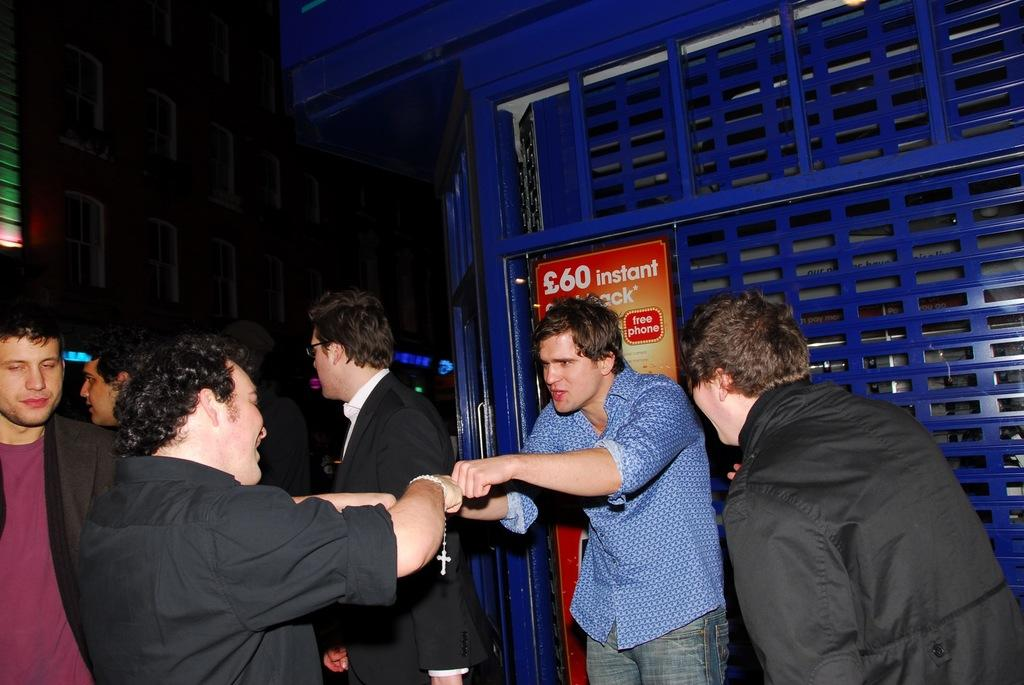How many persons are visible in the image? There are persons standing in the image. What can be seen in the background of the image? There are objects in the background of the image. What colors are the objects in the background? The objects are black and blue in color. What is written on the board in the image? There is a board with text written on it in the image. What type of pet is sitting on the board in the image? There is no pet present in the image, and the board does not have a pet sitting on it. 